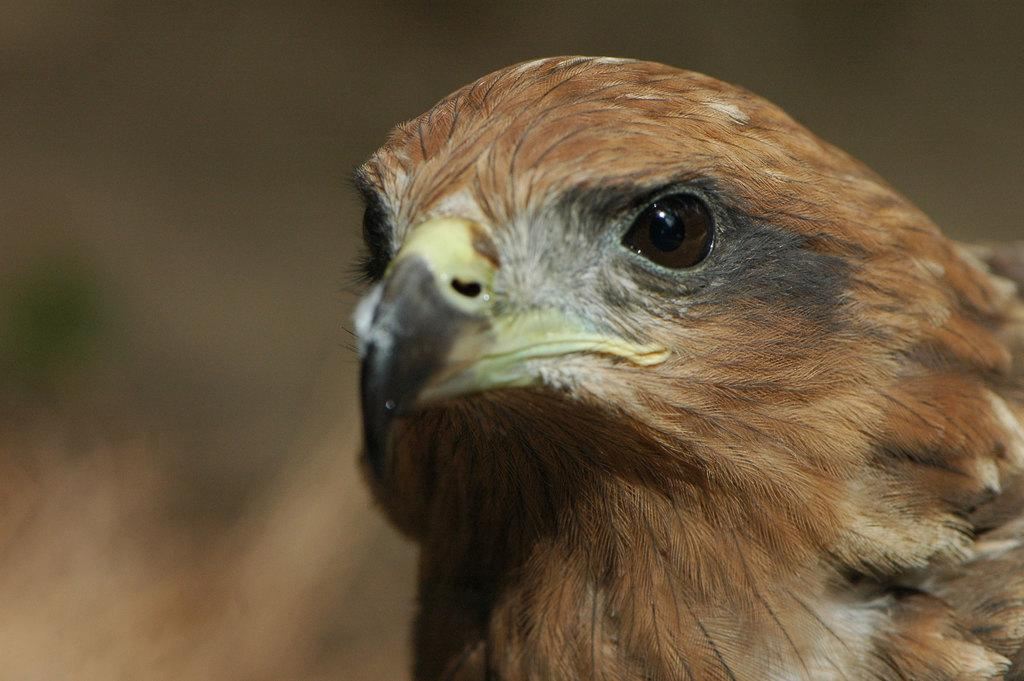What type of animal can be seen in the image? There is a bird in the image. Can you describe the background of the image? The background of the image is blurred. How many icicles are hanging from the bird's beak in the image? There are no icicles present in the image, as it features a bird with a blurred background. 